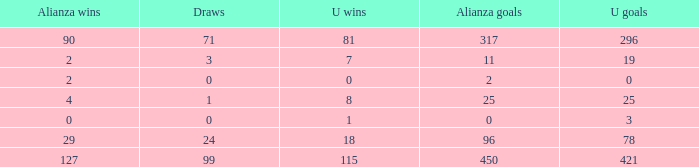What is the minimum draws, when alianza goals are fewer than 317, when u goals are below 3, and when alianza wins are under 2? None. 